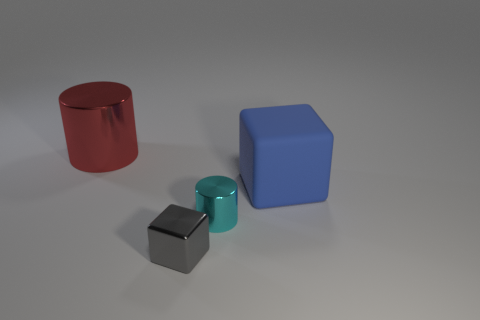Add 2 tiny cylinders. How many objects exist? 6 Subtract 0 gray cylinders. How many objects are left? 4 Subtract all blue rubber things. Subtract all large cylinders. How many objects are left? 2 Add 4 large blocks. How many large blocks are left? 5 Add 3 tiny metallic blocks. How many tiny metallic blocks exist? 4 